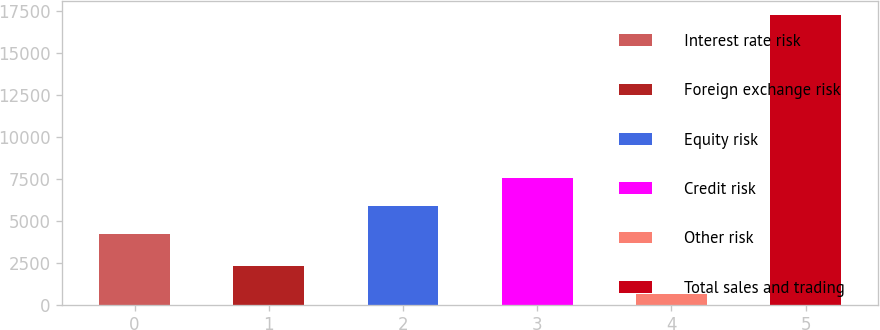<chart> <loc_0><loc_0><loc_500><loc_500><bar_chart><fcel>Interest rate risk<fcel>Foreign exchange risk<fcel>Equity risk<fcel>Credit risk<fcel>Other risk<fcel>Total sales and trading<nl><fcel>4246<fcel>2292.4<fcel>5910.4<fcel>7574.8<fcel>628<fcel>17272<nl></chart> 